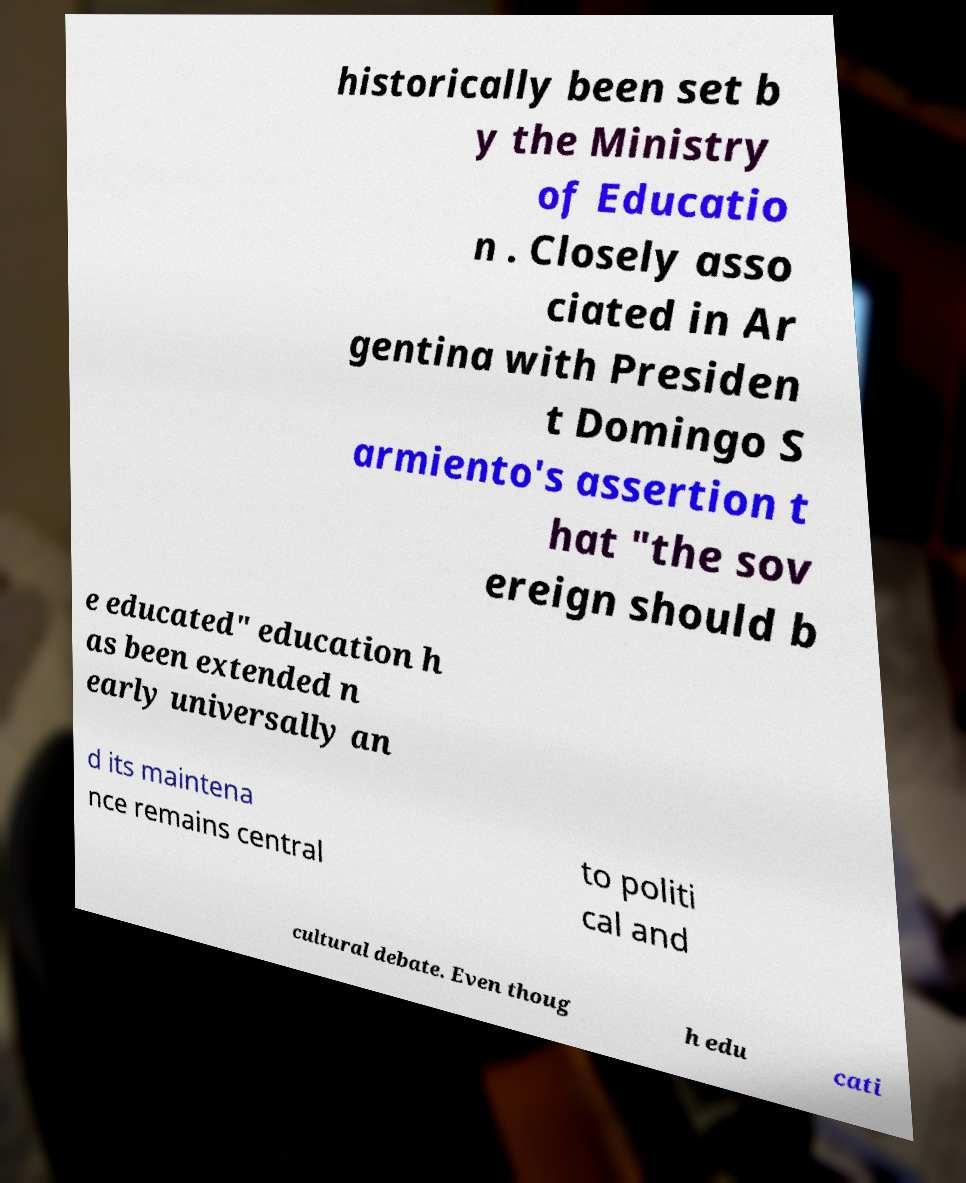Could you assist in decoding the text presented in this image and type it out clearly? historically been set b y the Ministry of Educatio n . Closely asso ciated in Ar gentina with Presiden t Domingo S armiento's assertion t hat "the sov ereign should b e educated" education h as been extended n early universally an d its maintena nce remains central to politi cal and cultural debate. Even thoug h edu cati 